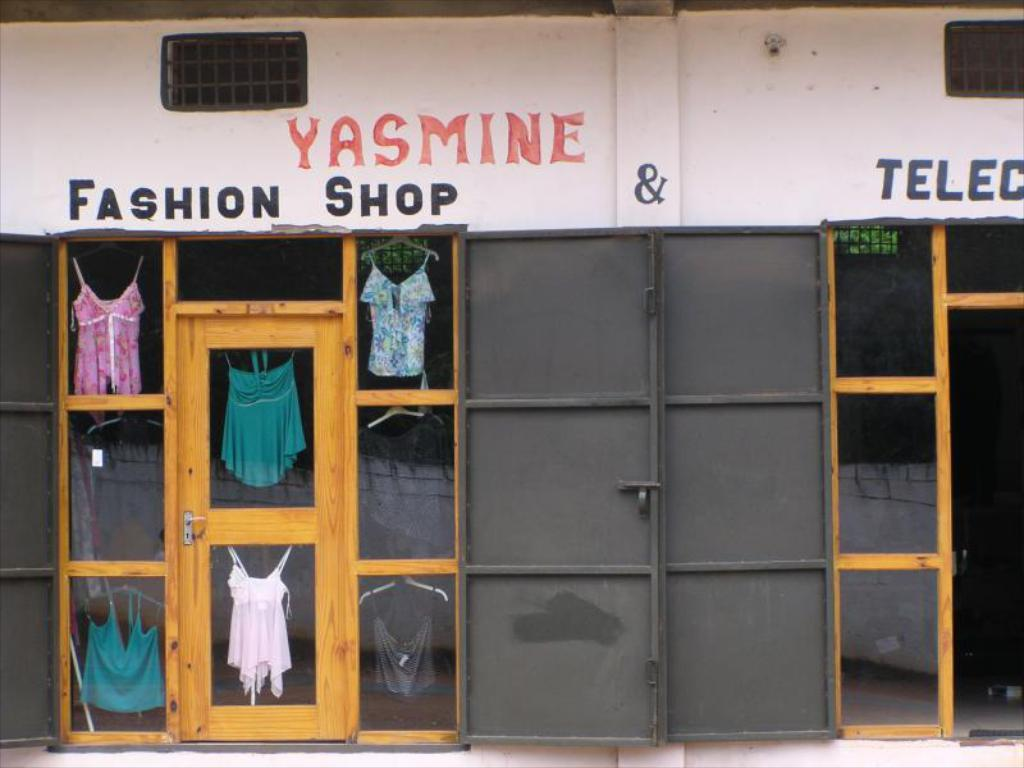<image>
Relay a brief, clear account of the picture shown. A storefront with the name Yasmine on top of it. 